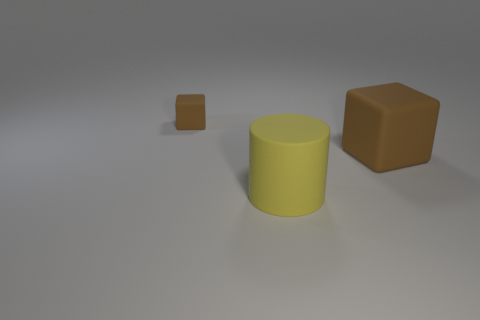How many objects are matte objects that are behind the cylinder or rubber things behind the yellow rubber cylinder? There is one matte brown cube behind the yellow cylinder. No rubber objects are present behind it. So in total, there is only one matte object behind the yellow cylinder. 